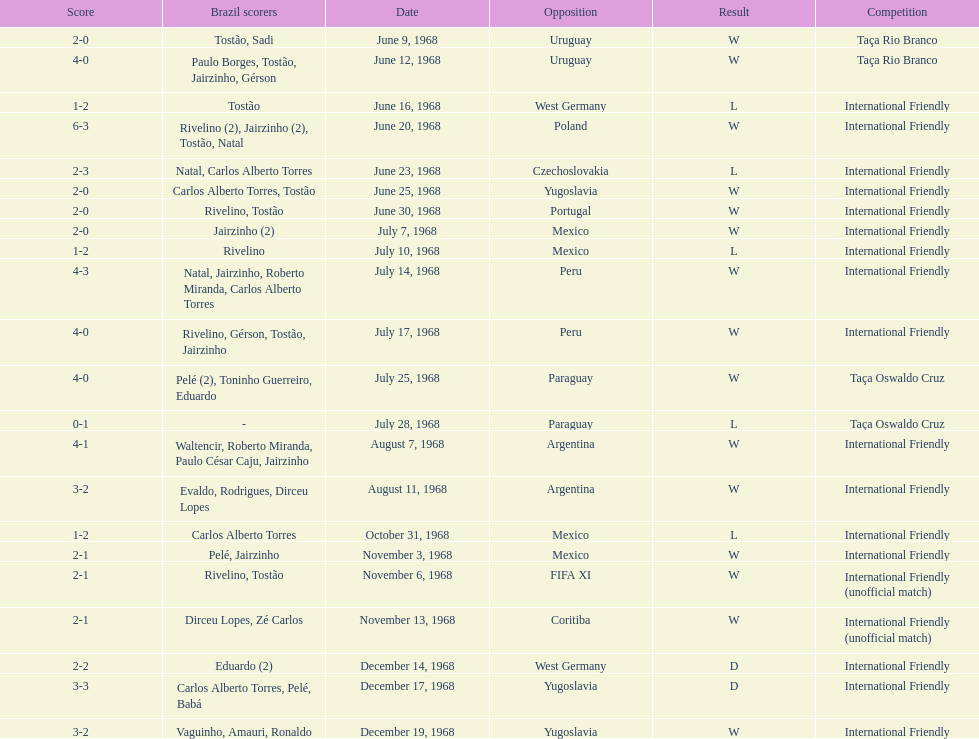Total number of wins 15. 